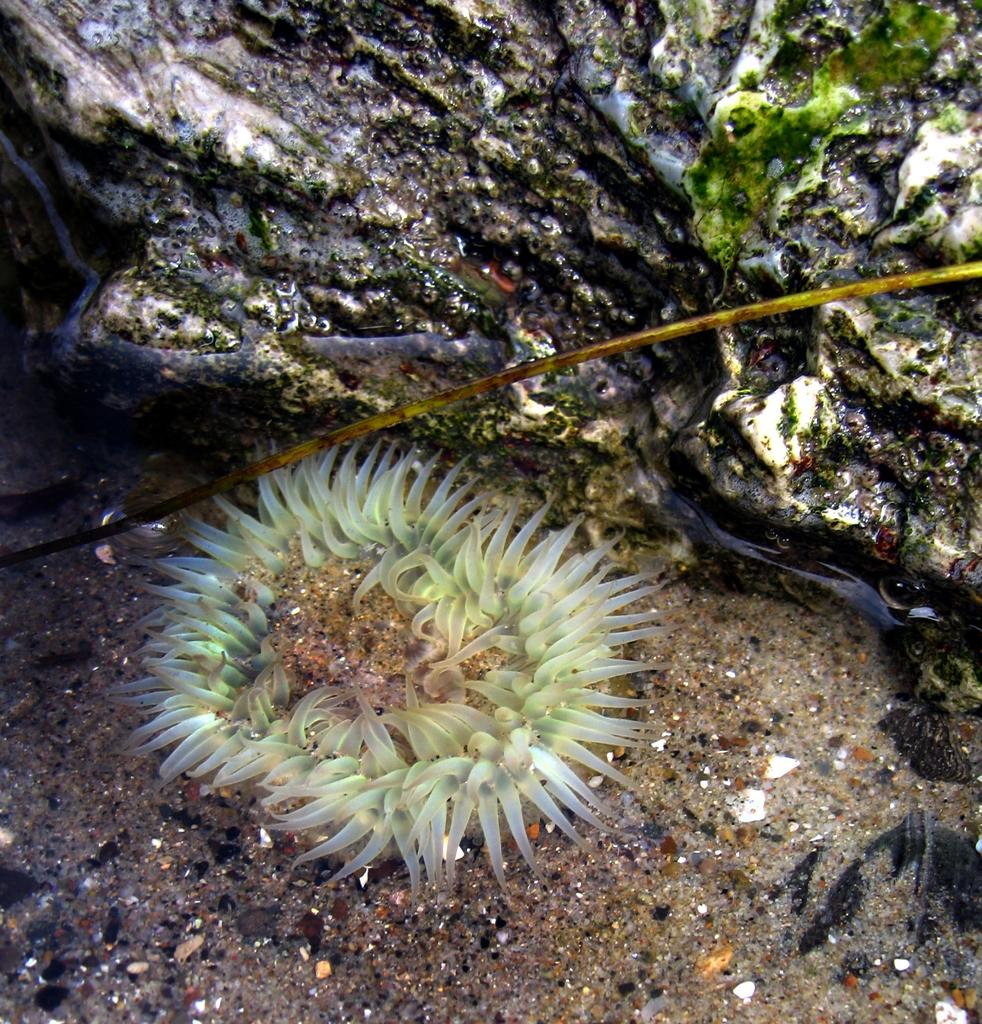What type of plant life is present in the image? There is chlorophyta and algae in the image. What is the surface visible in the image? There is ground visible in the image. What type of vein is visible in the image? There is no vein present in the image; it features chlorophyta and algae in a natural setting. 